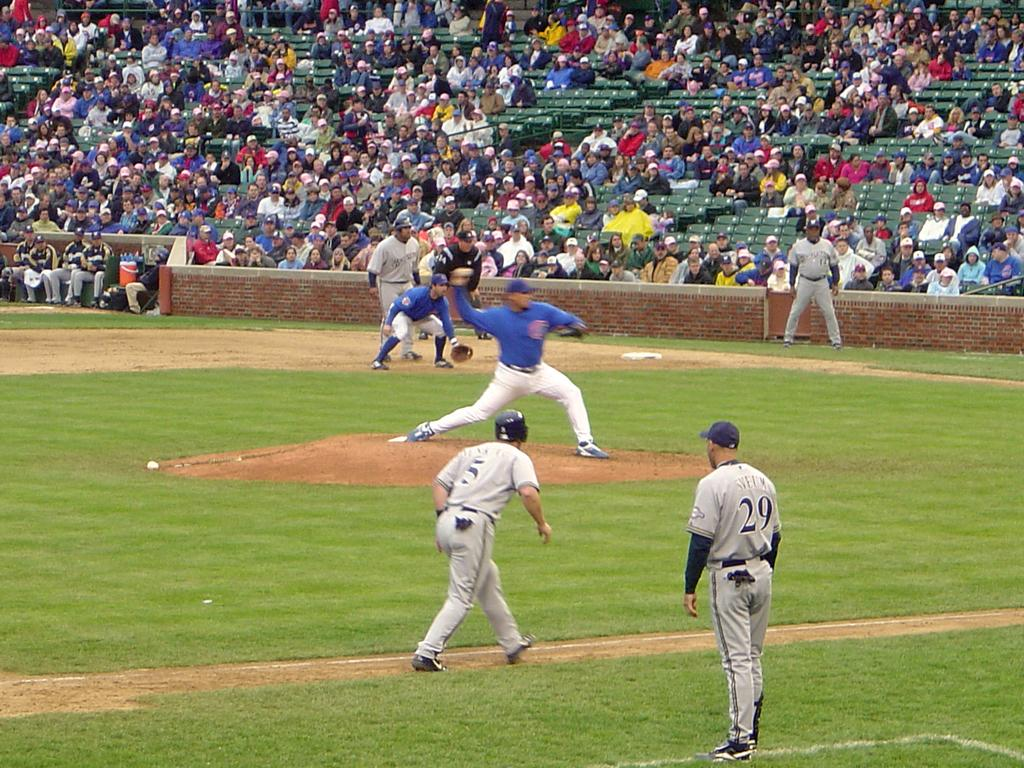<image>
Write a terse but informative summary of the picture. The baseball player that is running between 3rd base and home is number 5. 